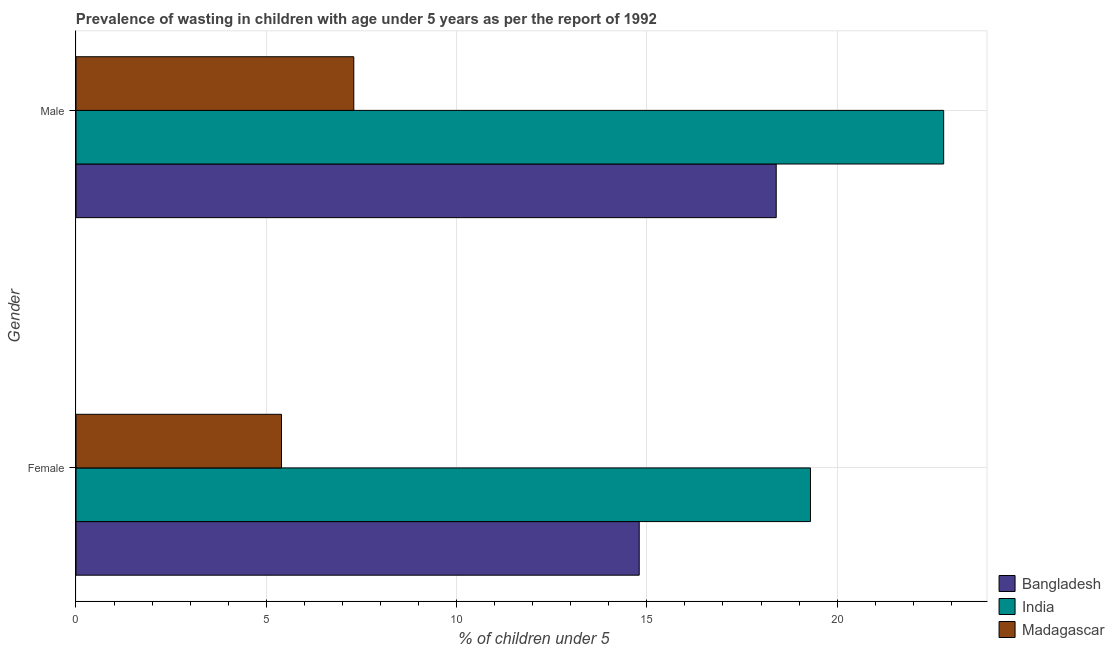How many different coloured bars are there?
Your response must be concise. 3. How many groups of bars are there?
Provide a succinct answer. 2. Are the number of bars per tick equal to the number of legend labels?
Provide a succinct answer. Yes. Are the number of bars on each tick of the Y-axis equal?
Give a very brief answer. Yes. What is the label of the 2nd group of bars from the top?
Provide a short and direct response. Female. What is the percentage of undernourished male children in India?
Keep it short and to the point. 22.8. Across all countries, what is the maximum percentage of undernourished female children?
Provide a succinct answer. 19.3. Across all countries, what is the minimum percentage of undernourished female children?
Offer a very short reply. 5.4. In which country was the percentage of undernourished male children minimum?
Provide a succinct answer. Madagascar. What is the total percentage of undernourished female children in the graph?
Provide a short and direct response. 39.5. What is the difference between the percentage of undernourished male children in Madagascar and that in Bangladesh?
Your response must be concise. -11.1. What is the difference between the percentage of undernourished male children in India and the percentage of undernourished female children in Bangladesh?
Your answer should be compact. 8. What is the average percentage of undernourished male children per country?
Offer a very short reply. 16.17. What is the difference between the percentage of undernourished male children and percentage of undernourished female children in Bangladesh?
Your response must be concise. 3.6. In how many countries, is the percentage of undernourished female children greater than 7 %?
Give a very brief answer. 2. What is the ratio of the percentage of undernourished male children in Madagascar to that in India?
Ensure brevity in your answer.  0.32. What does the 3rd bar from the top in Female represents?
Keep it short and to the point. Bangladesh. What does the 3rd bar from the bottom in Female represents?
Provide a succinct answer. Madagascar. How many bars are there?
Provide a succinct answer. 6. How many countries are there in the graph?
Ensure brevity in your answer.  3. Are the values on the major ticks of X-axis written in scientific E-notation?
Your answer should be very brief. No. Does the graph contain any zero values?
Your answer should be very brief. No. Where does the legend appear in the graph?
Provide a short and direct response. Bottom right. How many legend labels are there?
Offer a terse response. 3. What is the title of the graph?
Your answer should be compact. Prevalence of wasting in children with age under 5 years as per the report of 1992. What is the label or title of the X-axis?
Provide a short and direct response.  % of children under 5. What is the  % of children under 5 in Bangladesh in Female?
Offer a very short reply. 14.8. What is the  % of children under 5 in India in Female?
Offer a very short reply. 19.3. What is the  % of children under 5 of Madagascar in Female?
Provide a short and direct response. 5.4. What is the  % of children under 5 of Bangladesh in Male?
Ensure brevity in your answer.  18.4. What is the  % of children under 5 in India in Male?
Offer a terse response. 22.8. What is the  % of children under 5 of Madagascar in Male?
Ensure brevity in your answer.  7.3. Across all Gender, what is the maximum  % of children under 5 in Bangladesh?
Your answer should be very brief. 18.4. Across all Gender, what is the maximum  % of children under 5 in India?
Your response must be concise. 22.8. Across all Gender, what is the maximum  % of children under 5 of Madagascar?
Offer a terse response. 7.3. Across all Gender, what is the minimum  % of children under 5 of Bangladesh?
Provide a short and direct response. 14.8. Across all Gender, what is the minimum  % of children under 5 of India?
Provide a succinct answer. 19.3. Across all Gender, what is the minimum  % of children under 5 in Madagascar?
Offer a very short reply. 5.4. What is the total  % of children under 5 in Bangladesh in the graph?
Keep it short and to the point. 33.2. What is the total  % of children under 5 in India in the graph?
Keep it short and to the point. 42.1. What is the total  % of children under 5 of Madagascar in the graph?
Ensure brevity in your answer.  12.7. What is the difference between the  % of children under 5 of Bangladesh in Female and that in Male?
Your answer should be very brief. -3.6. What is the difference between the  % of children under 5 in India in Female and that in Male?
Offer a terse response. -3.5. What is the difference between the  % of children under 5 in Bangladesh in Female and the  % of children under 5 in Madagascar in Male?
Offer a terse response. 7.5. What is the average  % of children under 5 in India per Gender?
Your answer should be very brief. 21.05. What is the average  % of children under 5 of Madagascar per Gender?
Your response must be concise. 6.35. What is the difference between the  % of children under 5 in India and  % of children under 5 in Madagascar in Male?
Keep it short and to the point. 15.5. What is the ratio of the  % of children under 5 in Bangladesh in Female to that in Male?
Your answer should be compact. 0.8. What is the ratio of the  % of children under 5 of India in Female to that in Male?
Give a very brief answer. 0.85. What is the ratio of the  % of children under 5 of Madagascar in Female to that in Male?
Ensure brevity in your answer.  0.74. What is the difference between the highest and the second highest  % of children under 5 of Bangladesh?
Offer a terse response. 3.6. What is the difference between the highest and the second highest  % of children under 5 in India?
Provide a short and direct response. 3.5. 